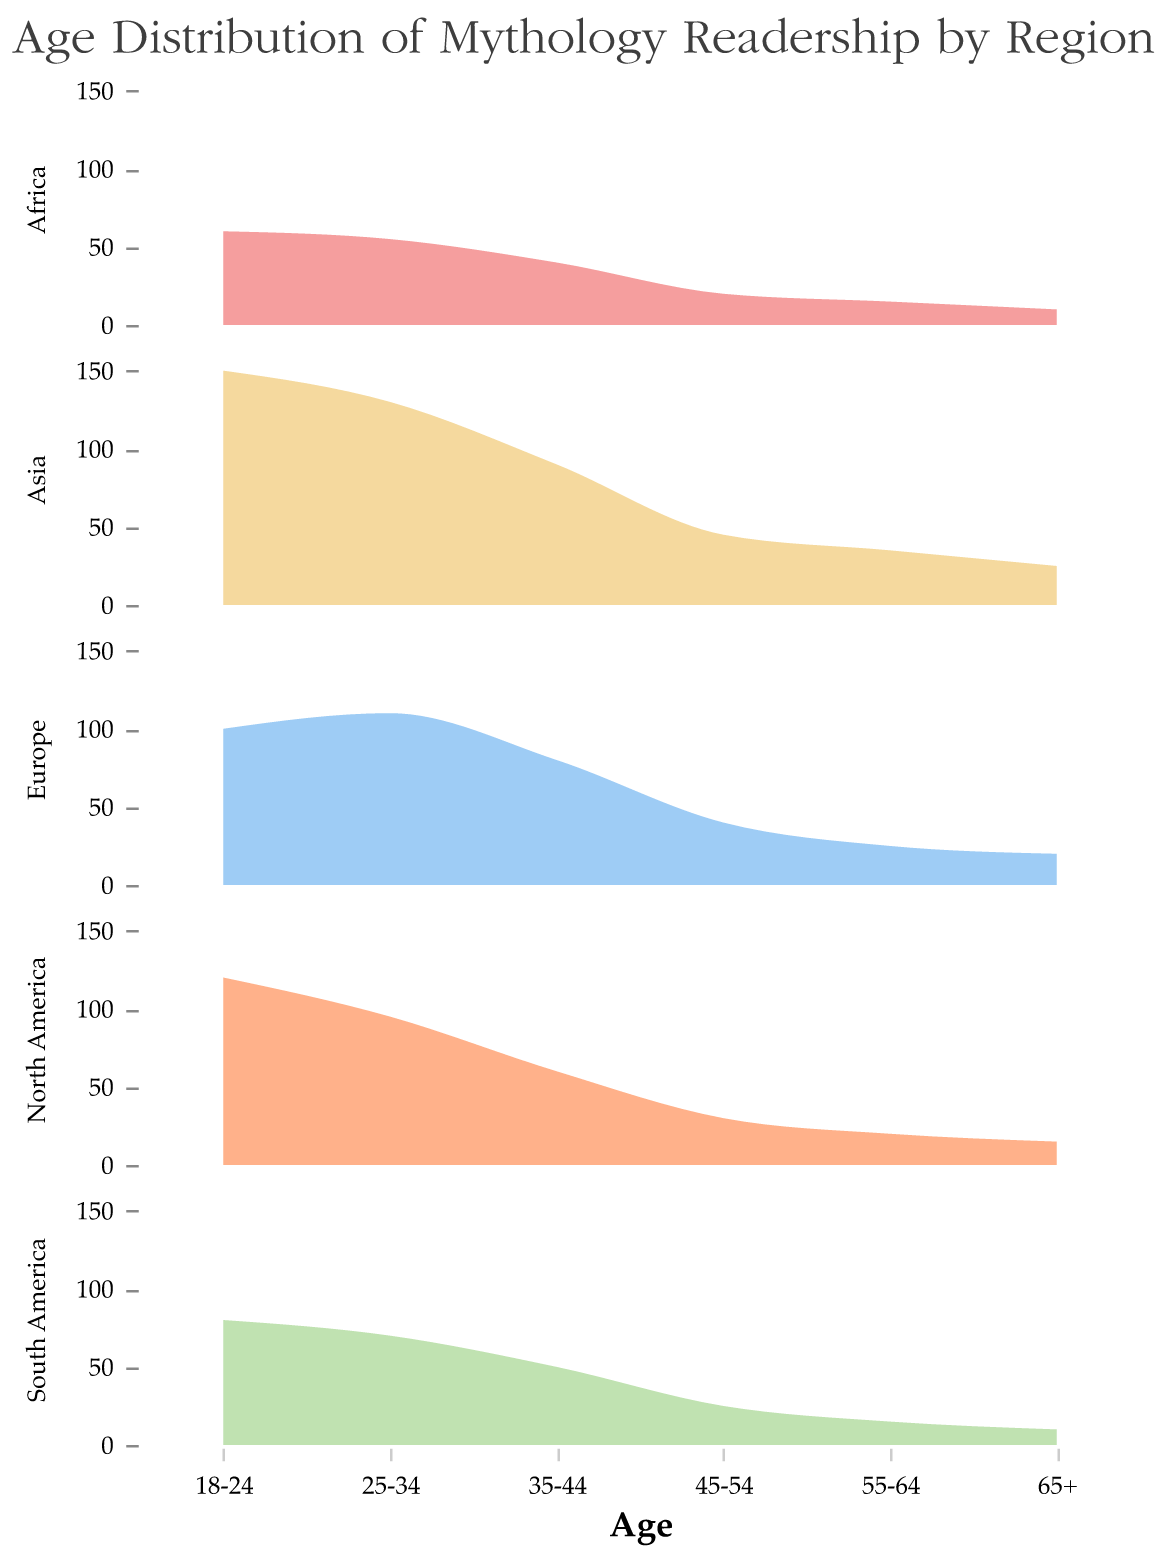What is the age group with the highest frequency of readers in North America? In the North America subplot, the highest peak corresponds to the "18-24" age group. The frequency for "18-24" is 120, which is higher than any other age group for North America.
Answer: 18-24 Which region has the lowest frequency of readers in the "65+" age group? By looking at the lowest part of each subplot for the "65+" age group, South America and Africa have the same lowest frequency of 10.
Answer: South America and Africa Compare the frequency of readers aged "25-34" between Europe and Asia. The frequencies for the "25-34" age group in Europe and Asia are 110 and 130 respectively, with Asia being higher.
Answer: Asia Which age group has the lowest frequency in Europe? In the Europe subplot, the lowest peak is at the "65+" age group with a frequency of 20.
Answer: 65+ What is the combined frequency of readers aged "18-24" in North America and Europe? Add the frequencies of the "18-24" age group for North America and Europe: 120 (North America) + 100 (Europe) = 220.
Answer: 220 Which region has the most diverse age distribution among its readers? The diversity can be inferred from the spread and size of peaks across all age groups. Asia has significant frequencies across all age groups, ranging from 150 (highest) to 25 (lowest), showing a broad distribution.
Answer: Asia How does the reader frequency of the "35-44" age group in South America compare to its "45-54" age group? Compare the frequency of "35-44" (50) to "45-54" (25) in South America subplot. The frequency for "35-44" is greater.
Answer: 35-44 Which age group in Asia has the highest peak, and what is its frequency? The highest peak in the Asia subplot appears at the "18-24" age group with a frequency of 150.
Answer: 18-24, 150 In which regions does the "25-34" age group not have the highest frequency? For each subplot, check if "25-34" is the highest. It is not the highest in North America (here it's "18-24" with 120) and not in South America (here it's "18-24" with 80).
Answer: North America, South America 